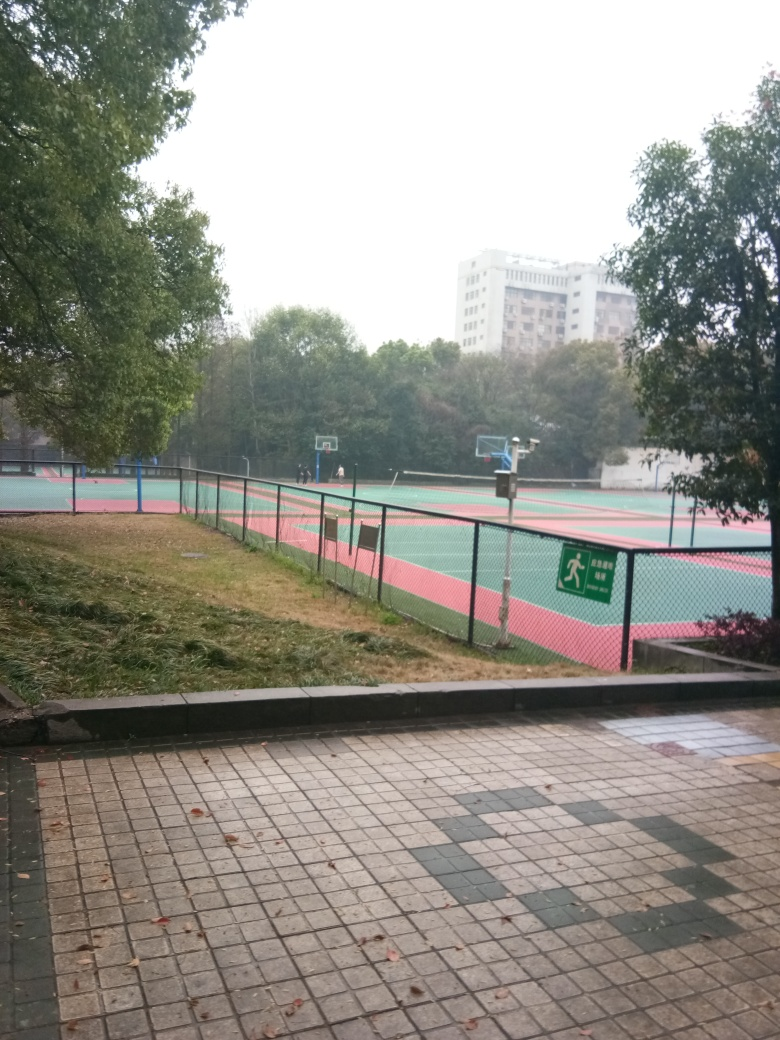Are there any quality issues with this image? Yes, the image appears to be slightly blurred, which affects the overall clarity. There's also an overcast sky leading to a lack of vibrant colors, which could be described as a quality issue if the intent was to showcase the area in more vivid detail. 